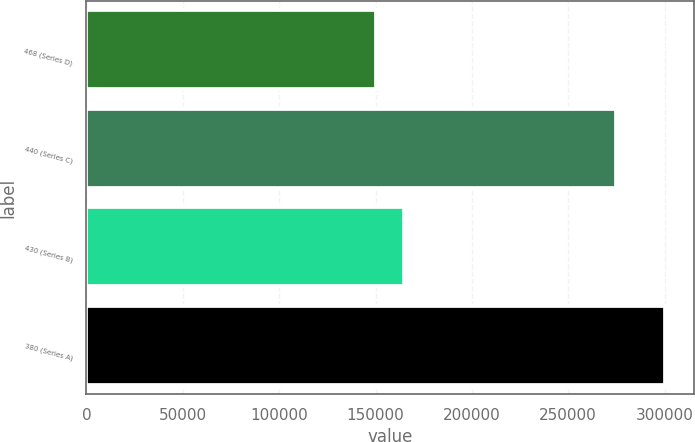Convert chart. <chart><loc_0><loc_0><loc_500><loc_500><bar_chart><fcel>468 (Series D)<fcel>440 (Series C)<fcel>430 (Series B)<fcel>380 (Series A)<nl><fcel>150000<fcel>274720<fcel>165000<fcel>300000<nl></chart> 